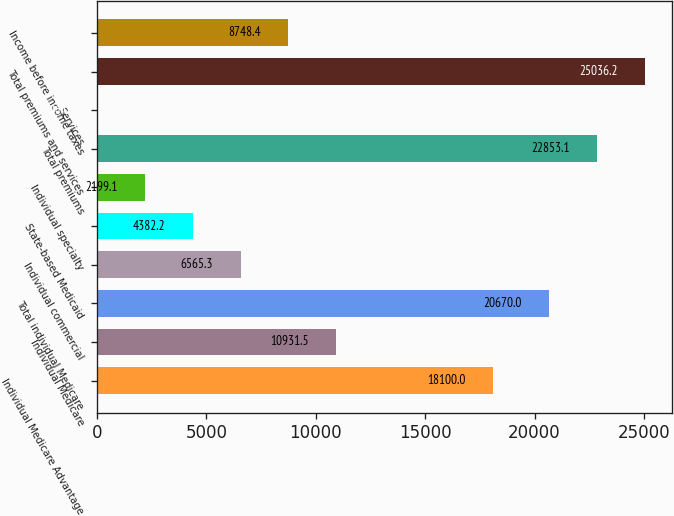<chart> <loc_0><loc_0><loc_500><loc_500><bar_chart><fcel>Individual Medicare Advantage<fcel>Individual Medicare<fcel>Total individual Medicare<fcel>Individual commercial<fcel>State-based Medicaid<fcel>Individual specialty<fcel>Total premiums<fcel>Services<fcel>Total premiums and services<fcel>Income before income taxes<nl><fcel>18100<fcel>10931.5<fcel>20670<fcel>6565.3<fcel>4382.2<fcel>2199.1<fcel>22853.1<fcel>16<fcel>25036.2<fcel>8748.4<nl></chart> 